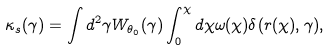Convert formula to latex. <formula><loc_0><loc_0><loc_500><loc_500>\kappa _ { s } ( \gamma ) = \int d ^ { 2 } \gamma W _ { \theta _ { 0 } } ( \gamma ) \int _ { 0 } ^ { \chi } d \chi \omega ( \chi ) \delta ( r ( \chi ) , \gamma ) ,</formula> 